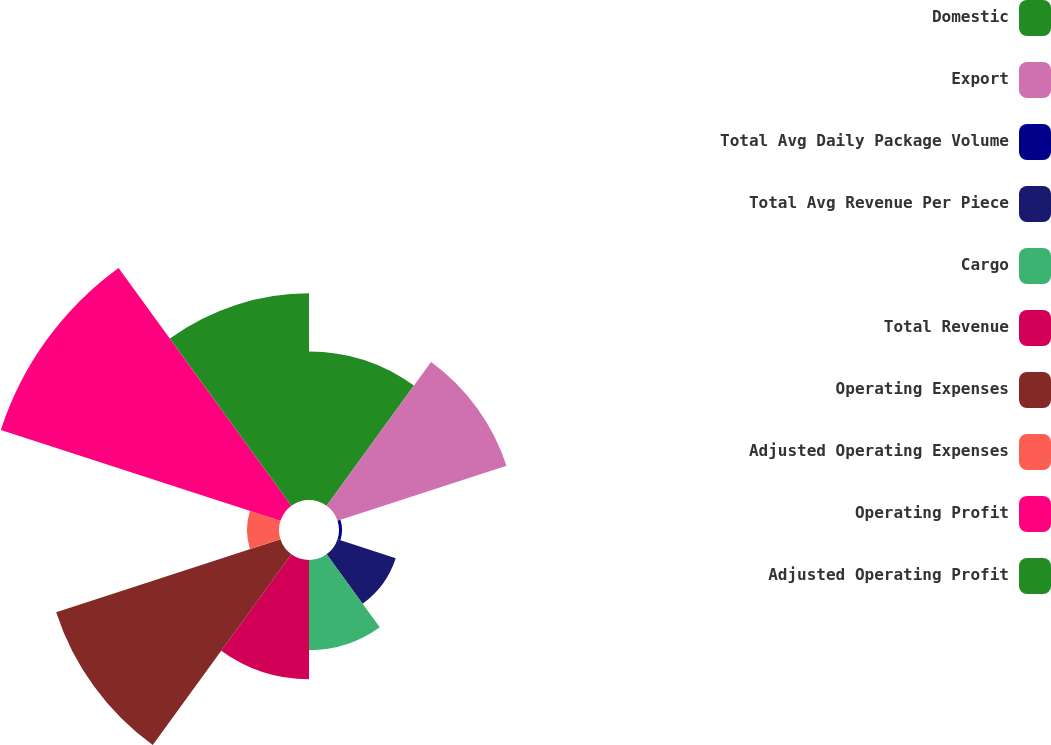Convert chart. <chart><loc_0><loc_0><loc_500><loc_500><pie_chart><fcel>Domestic<fcel>Export<fcel>Total Avg Daily Package Volume<fcel>Total Avg Revenue Per Piece<fcel>Cargo<fcel>Total Revenue<fcel>Operating Expenses<fcel>Adjusted Operating Expenses<fcel>Operating Profit<fcel>Adjusted Operating Profit<nl><fcel>10.85%<fcel>12.98%<fcel>0.22%<fcel>4.47%<fcel>6.6%<fcel>8.72%<fcel>17.23%<fcel>2.34%<fcel>21.48%<fcel>15.1%<nl></chart> 